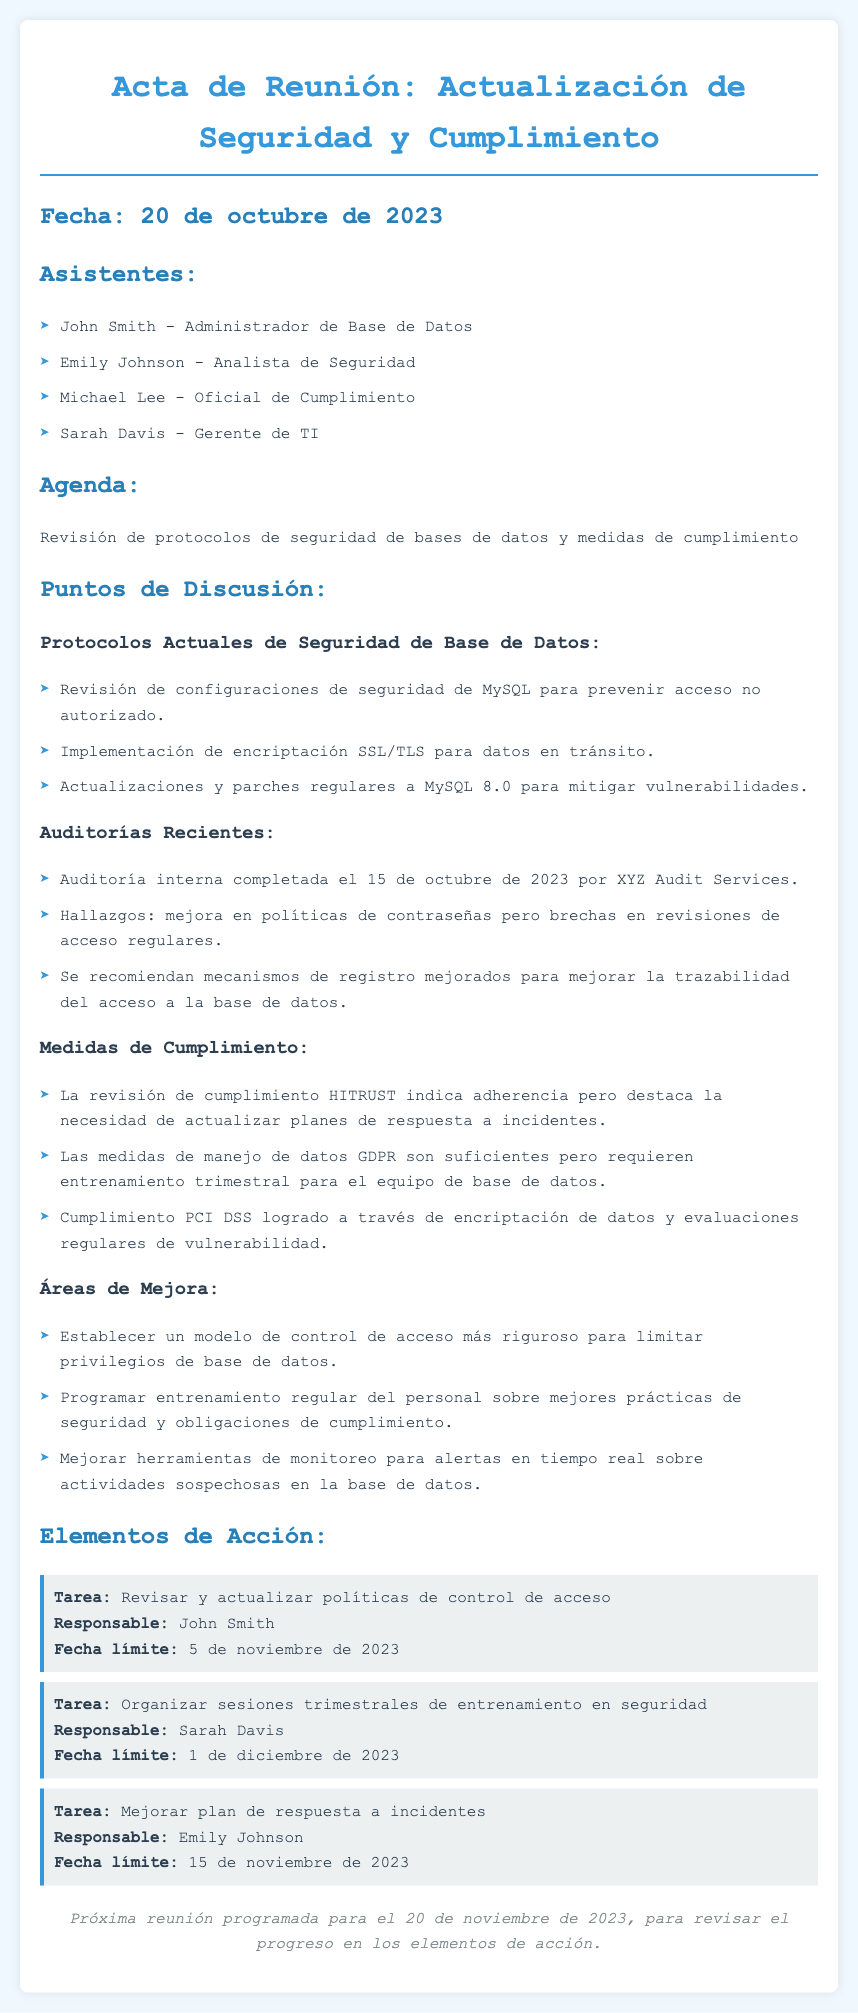¿Cuál es la fecha de la reunión? La fecha de la reunión se menciona al principio del documento.
Answer: 20 de octubre de 2023 ¿Quién es el responsable de revisar y actualizar políticas de control de acceso? Se menciona quién es el responsable de esta tarea en la sección de elementos de acción.
Answer: John Smith ¿Cuándo se completó la auditoría interna? La fecha de la auditoría interna se indica en la sección de auditorías recientes.
Answer: 15 de octubre de 2023 ¿Qué medidas se requieren para mejorar la trazabilidad del acceso a la base de datos? Se detalla en los hallazgos de la auditoría reciente.
Answer: Mecanismos de registro mejorados ¿Cuáles son las medidas de manejo de datos mencionadas en el cumplimiento? Se especifican las medidas que se están siguiendo en la sección correspondiente del documento.
Answer: Suficientes pero requieren entrenamiento trimestral ¿Cuándo está programada la próxima reunión? La fecha de la próxima reunión se menciona al final del documento.
Answer: 20 de noviembre de 2023 ¿Qué área necesita un modelo de control de acceso más riguroso? Se menciona en la sección de áreas de mejora.
Answer: Control de acceso ¿Cuál es la tarea asignada a Emily Johnson? Se identifica la tarea en la sección de elementos de acción.
Answer: Mejorar plan de respuesta a incidentes ¿Qué auditoría se completó el 15 de octubre de 2023? Se detalla en la sección de auditorías recientes.
Answer: Auditoría interna 